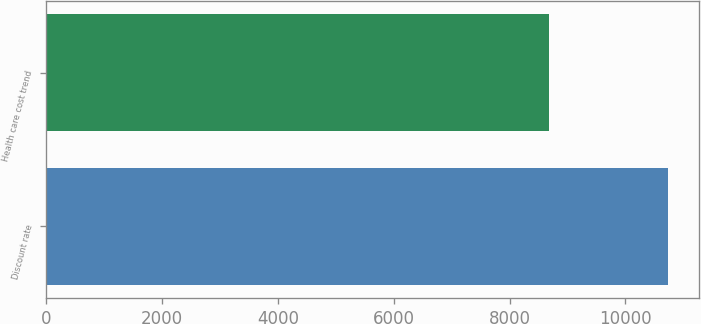Convert chart to OTSL. <chart><loc_0><loc_0><loc_500><loc_500><bar_chart><fcel>Discount rate<fcel>Health care cost trend<nl><fcel>10727<fcel>8675<nl></chart> 